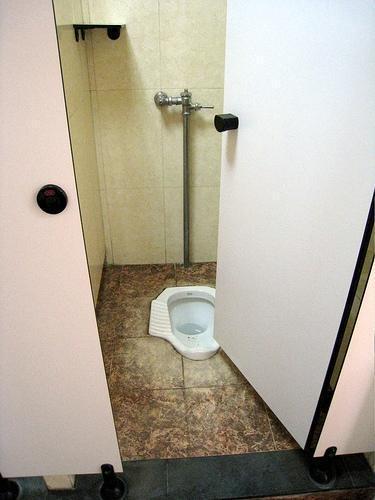How many doors are in the picture?
Give a very brief answer. 1. How many bathroom stalls are shown?
Give a very brief answer. 1. 